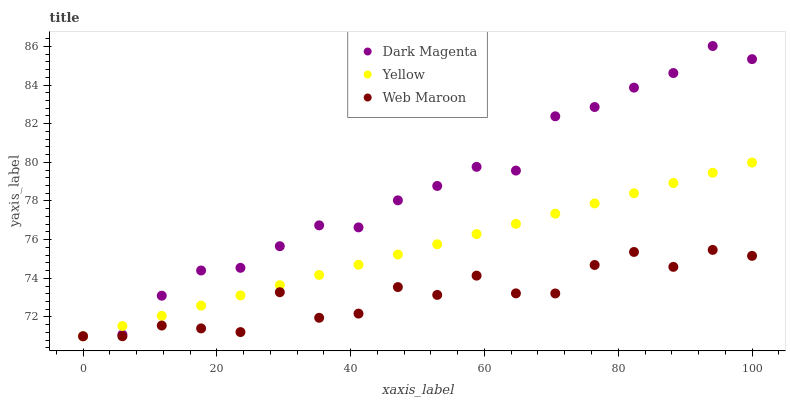Does Web Maroon have the minimum area under the curve?
Answer yes or no. Yes. Does Dark Magenta have the maximum area under the curve?
Answer yes or no. Yes. Does Yellow have the minimum area under the curve?
Answer yes or no. No. Does Yellow have the maximum area under the curve?
Answer yes or no. No. Is Yellow the smoothest?
Answer yes or no. Yes. Is Web Maroon the roughest?
Answer yes or no. Yes. Is Dark Magenta the smoothest?
Answer yes or no. No. Is Dark Magenta the roughest?
Answer yes or no. No. Does Web Maroon have the lowest value?
Answer yes or no. Yes. Does Dark Magenta have the highest value?
Answer yes or no. Yes. Does Yellow have the highest value?
Answer yes or no. No. Does Dark Magenta intersect Yellow?
Answer yes or no. Yes. Is Dark Magenta less than Yellow?
Answer yes or no. No. Is Dark Magenta greater than Yellow?
Answer yes or no. No. 